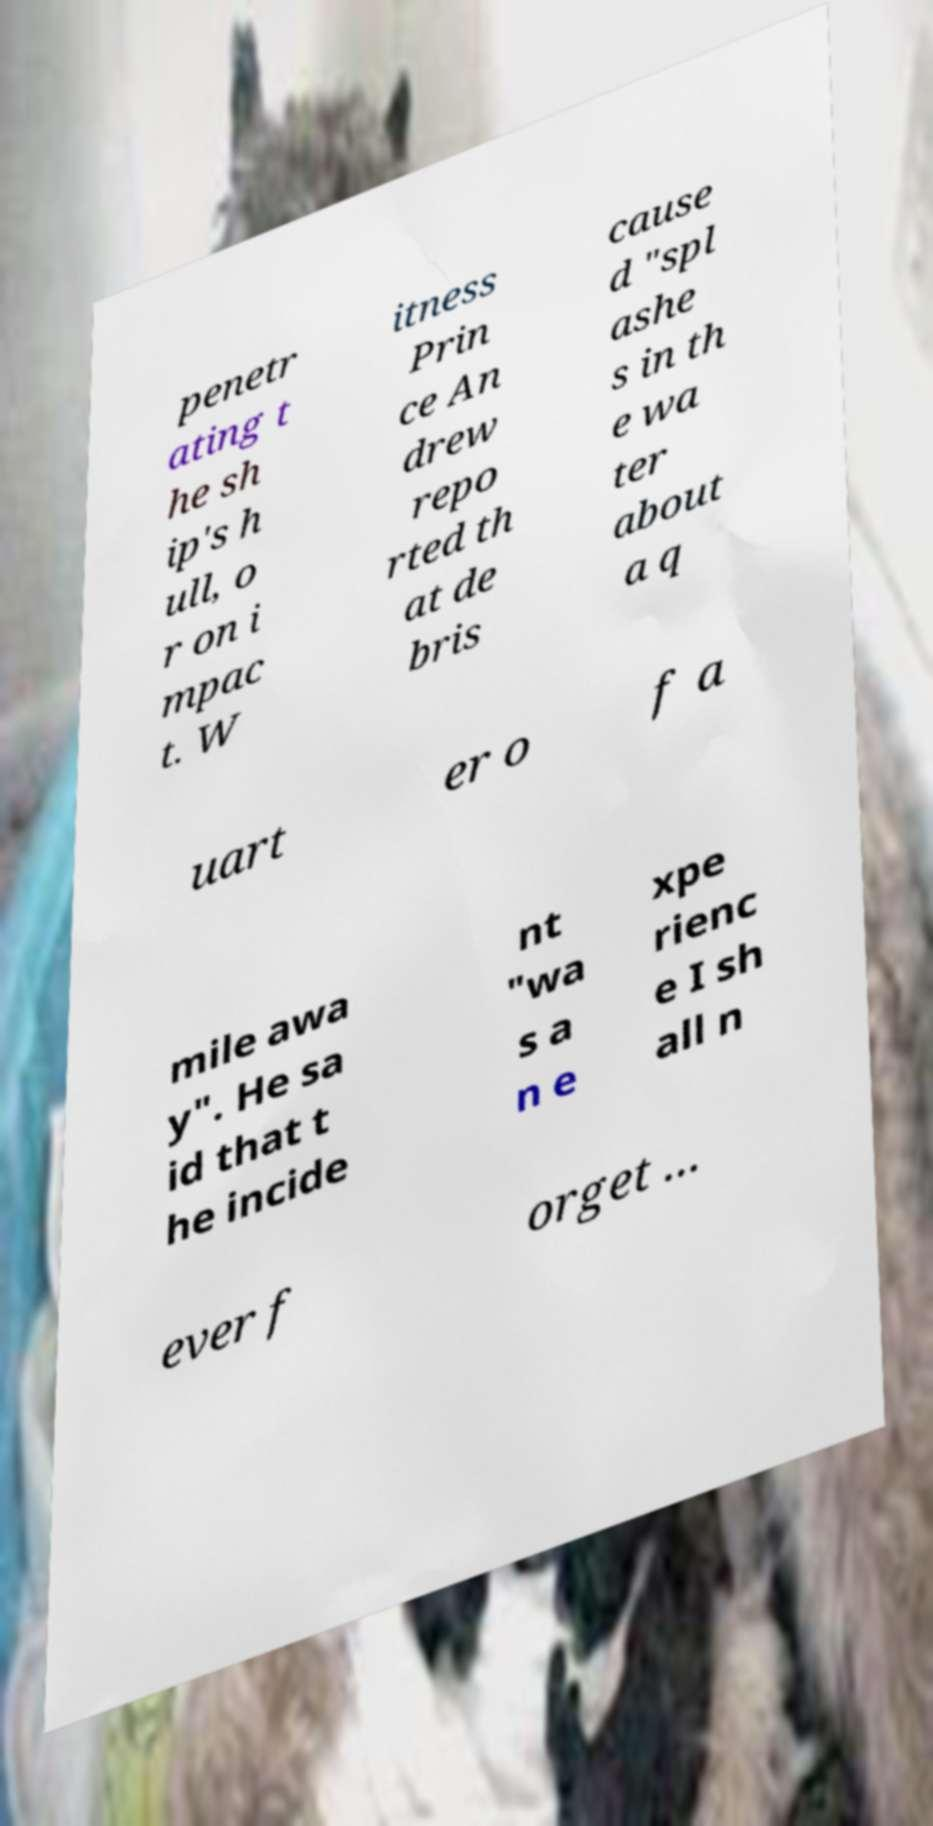Can you read and provide the text displayed in the image?This photo seems to have some interesting text. Can you extract and type it out for me? penetr ating t he sh ip's h ull, o r on i mpac t. W itness Prin ce An drew repo rted th at de bris cause d "spl ashe s in th e wa ter about a q uart er o f a mile awa y". He sa id that t he incide nt "wa s a n e xpe rienc e I sh all n ever f orget ... 